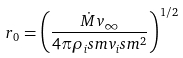<formula> <loc_0><loc_0><loc_500><loc_500>r _ { 0 } = \left ( \frac { \dot { M } v _ { \infty } } { 4 \pi \rho _ { i } s m v _ { i } s m ^ { 2 } } \right ) ^ { 1 / 2 }</formula> 